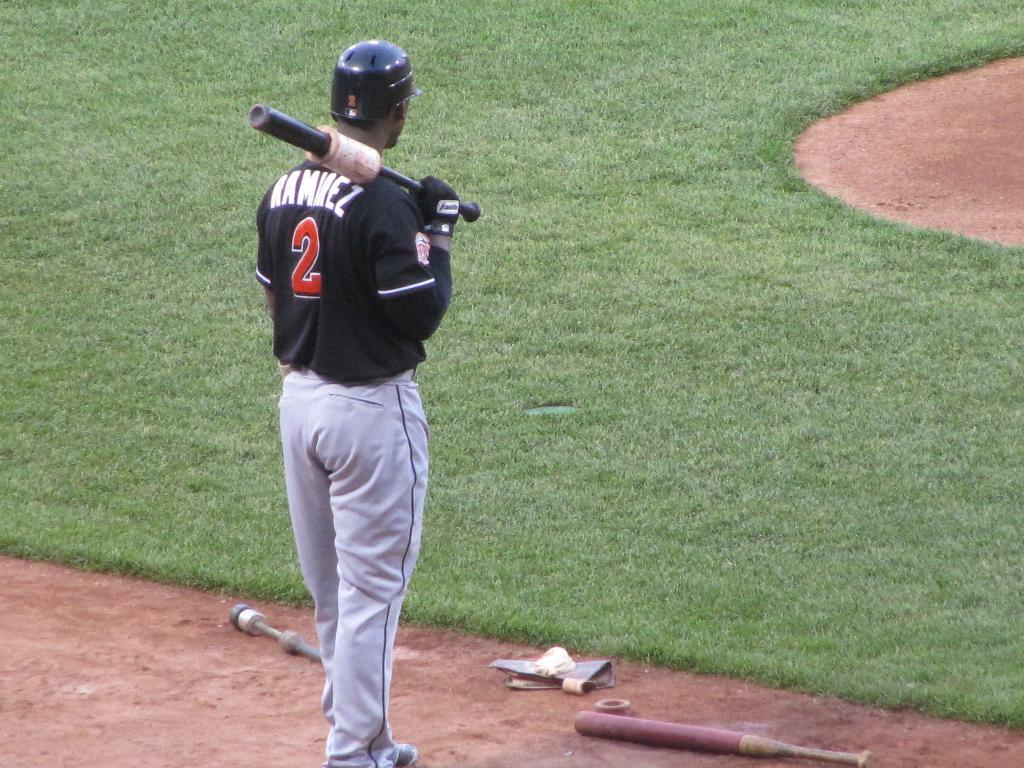<image>
Present a compact description of the photo's key features. A baseball player standing on the field with a bat over his shoulder with the name ramirez on his jersey. 